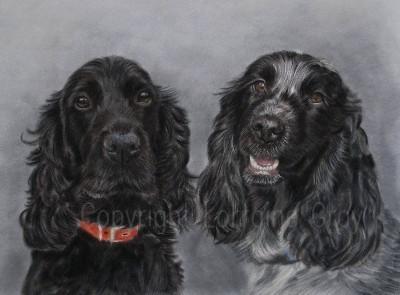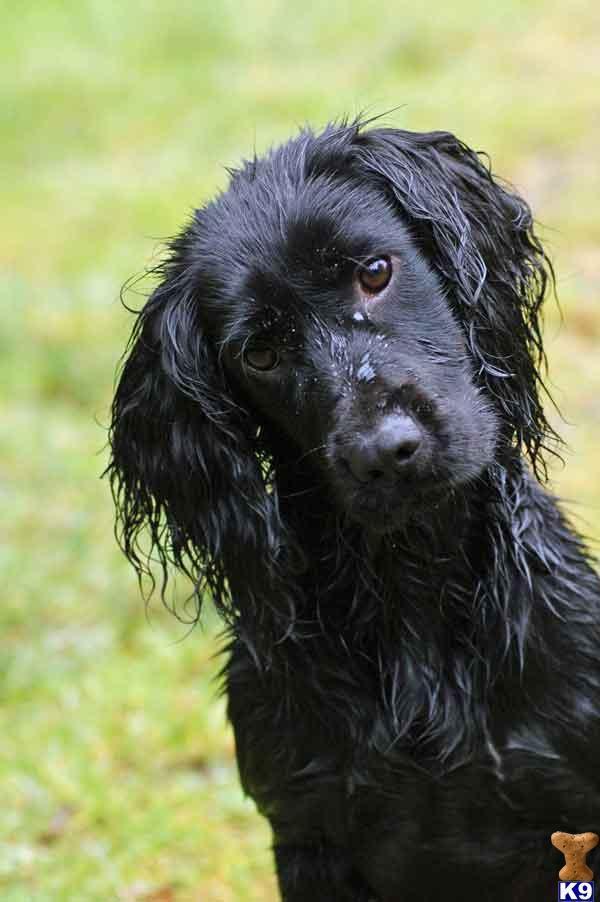The first image is the image on the left, the second image is the image on the right. Assess this claim about the two images: "All images show only dogs with black fur on their faces.". Correct or not? Answer yes or no. Yes. The first image is the image on the left, the second image is the image on the right. Assess this claim about the two images: "All of the dogs are black.". Correct or not? Answer yes or no. Yes. 